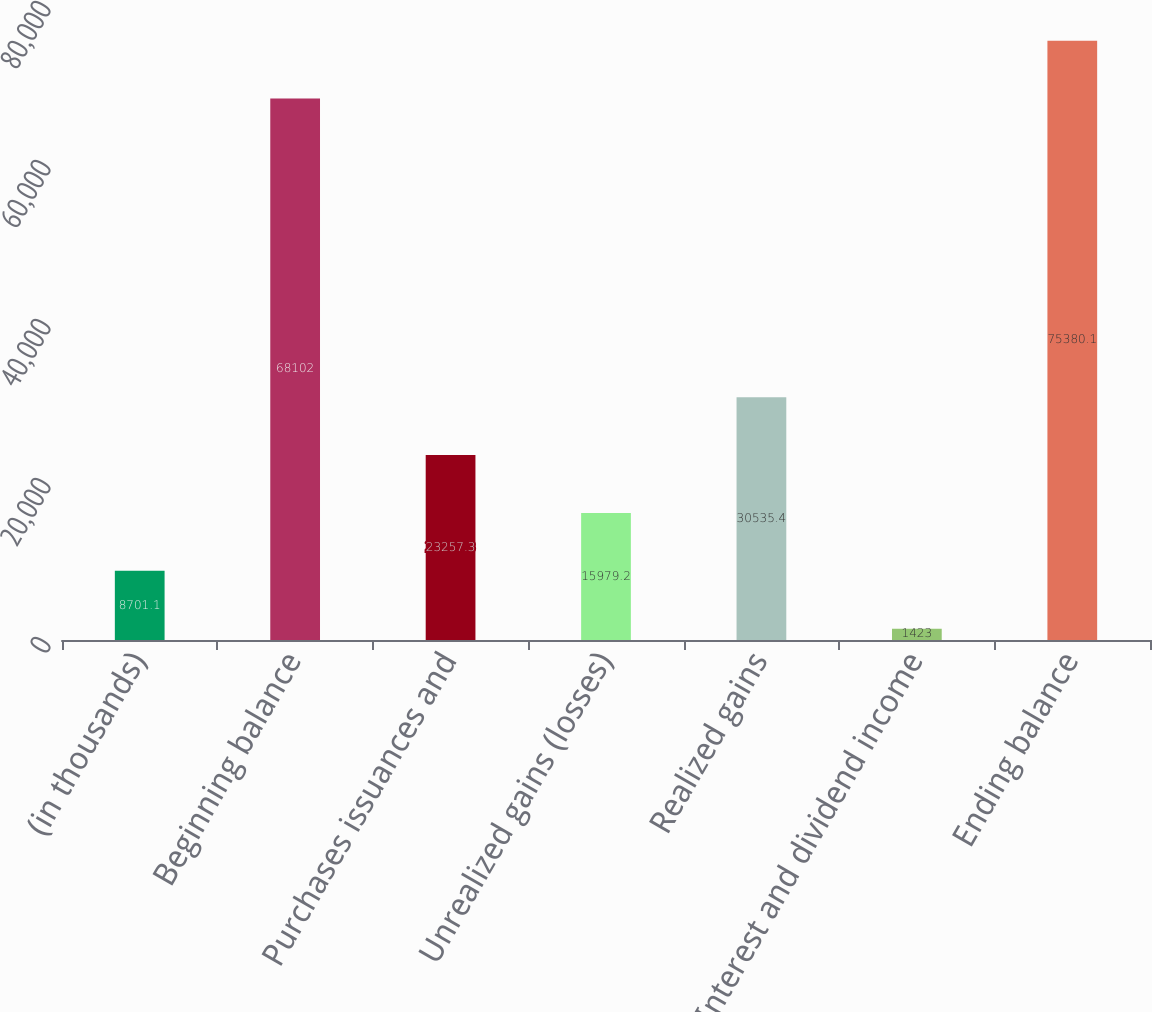<chart> <loc_0><loc_0><loc_500><loc_500><bar_chart><fcel>(in thousands)<fcel>Beginning balance<fcel>Purchases issuances and<fcel>Unrealized gains (losses)<fcel>Realized gains<fcel>Interest and dividend income<fcel>Ending balance<nl><fcel>8701.1<fcel>68102<fcel>23257.3<fcel>15979.2<fcel>30535.4<fcel>1423<fcel>75380.1<nl></chart> 